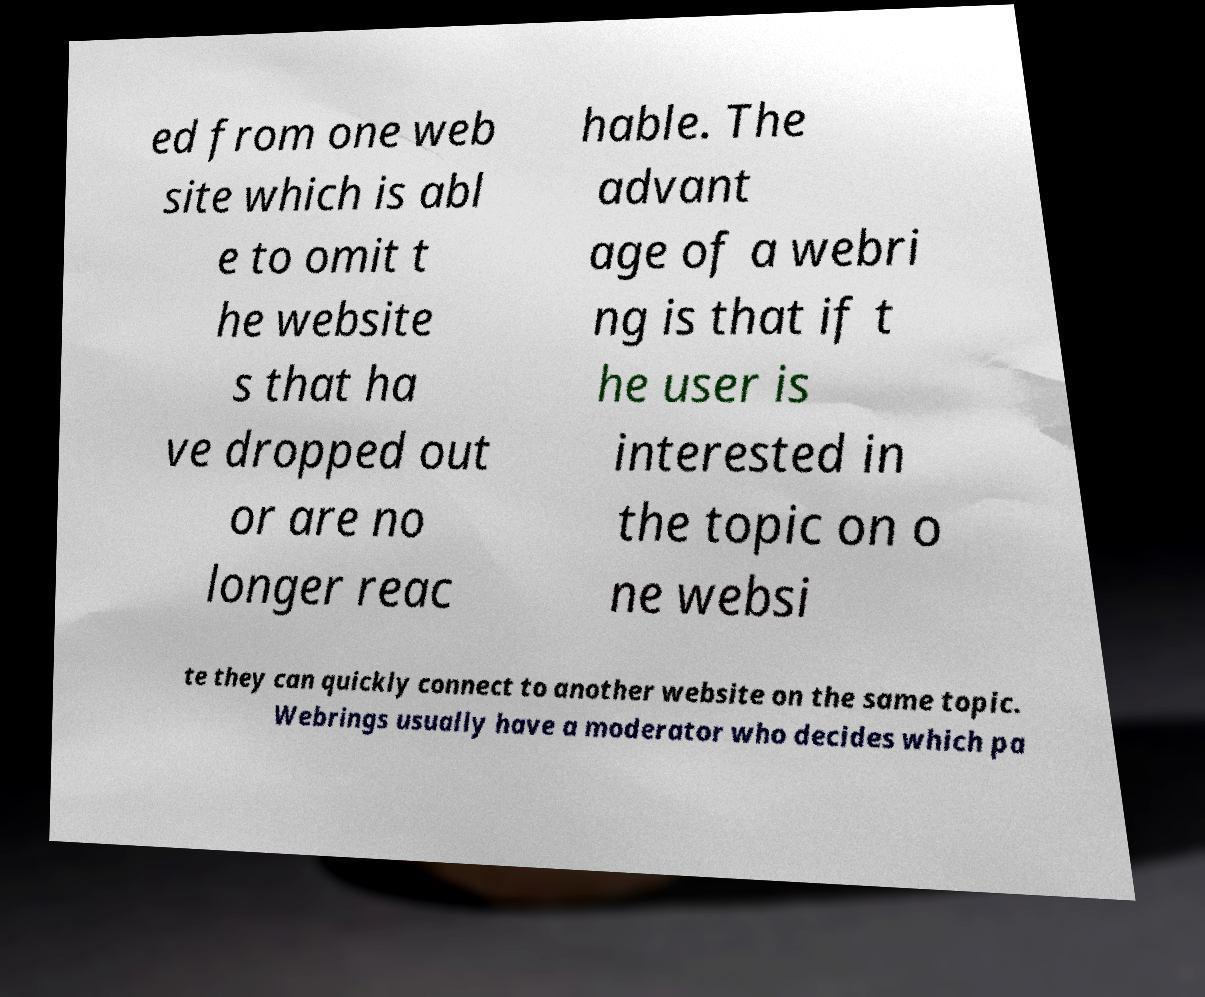Could you extract and type out the text from this image? ed from one web site which is abl e to omit t he website s that ha ve dropped out or are no longer reac hable. The advant age of a webri ng is that if t he user is interested in the topic on o ne websi te they can quickly connect to another website on the same topic. Webrings usually have a moderator who decides which pa 